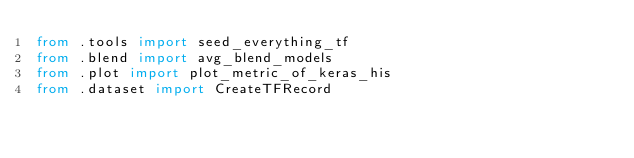Convert code to text. <code><loc_0><loc_0><loc_500><loc_500><_Python_>from .tools import seed_everything_tf
from .blend import avg_blend_models
from .plot import plot_metric_of_keras_his
from .dataset import CreateTFRecord
</code> 